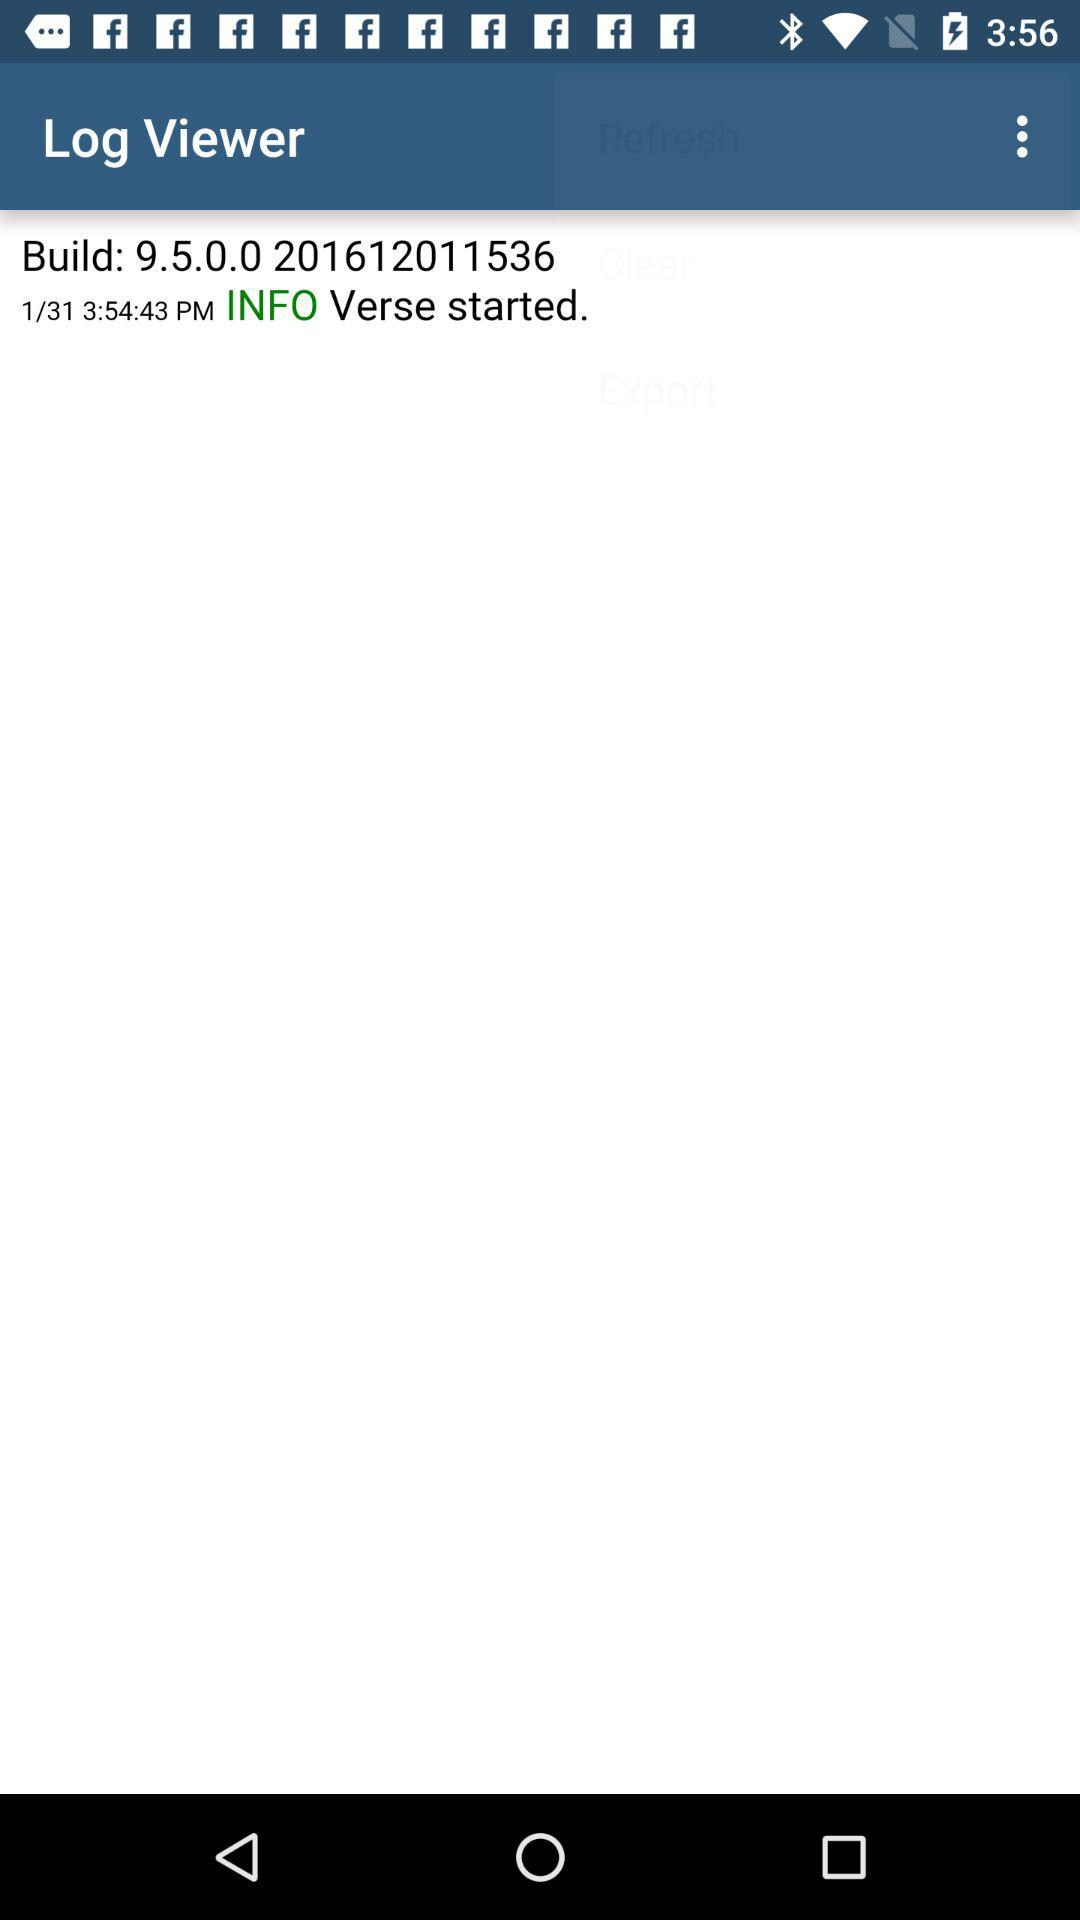What is the date? The date is January 31. 